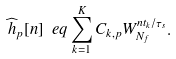Convert formula to latex. <formula><loc_0><loc_0><loc_500><loc_500>\widehat { h } _ { p } [ n ] \ e q \sum _ { k = 1 } ^ { K } C _ { k , p } W _ { N _ { f } } ^ { n t _ { k } / \tau _ { s } } .</formula> 